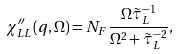<formula> <loc_0><loc_0><loc_500><loc_500>\chi ^ { \prime \prime } _ { L L } ( { q } , \Omega ) = N _ { F } \frac { \Omega \tilde { \tau } _ { L } ^ { - 1 } } { \Omega ^ { 2 } + \tilde { \tau } ^ { - 2 } _ { L } } ,</formula> 